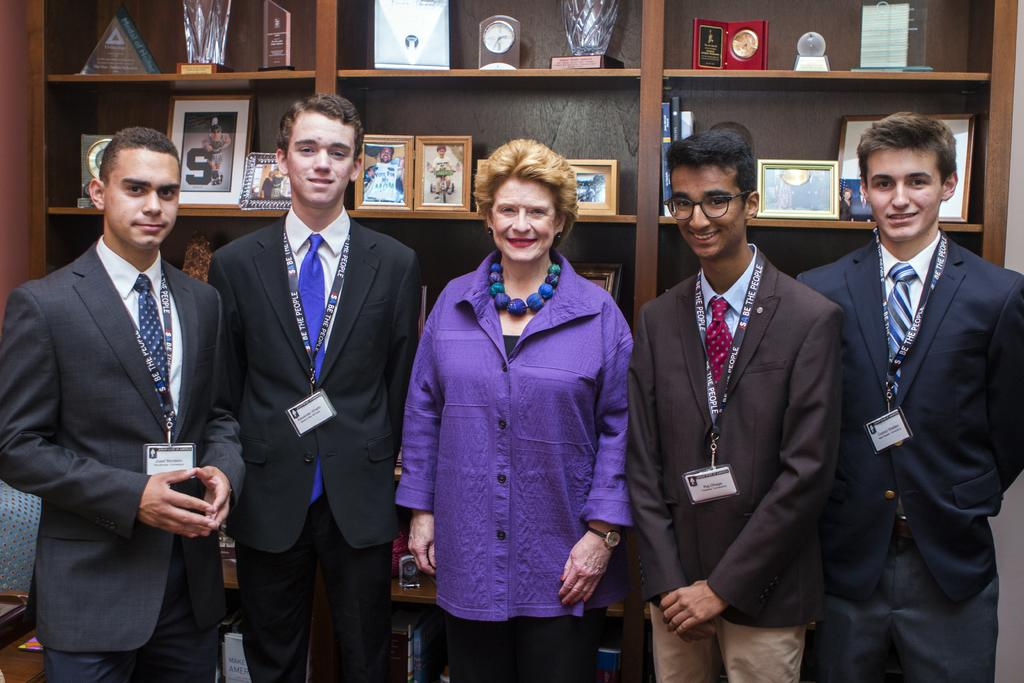What can be seen in the background of the image? In the background of the image, there is a clock, photo frames, and objects in racks. How many people are in the image? There is a woman and a man in the image. What is the man wearing that identifies him? The man is wearing an identity card. What type of clothing is the man wearing? The man is wearing a blazer and a tie. What is the man's facial expression in the image? The man is smiling in the image. How many letters are being distributed by the man in the image? There are no letters present in the image, and the man is not distributing anything. What type of earth can be seen in the photo frames in the image? There is no earth visible in the photo frames or anywhere else in the image. 